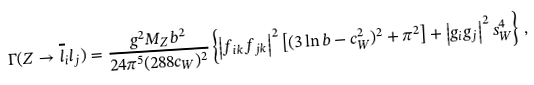<formula> <loc_0><loc_0><loc_500><loc_500>\Gamma ( Z \to \overline { l } _ { i } l _ { j } ) = \frac { g ^ { 2 } M _ { Z } b ^ { 2 } } { 2 4 \pi ^ { 5 } ( 2 8 8 c _ { W } ) ^ { 2 } } \left \{ \left | f _ { i k } f _ { j k } \right | ^ { 2 } \left [ ( 3 \ln b - c _ { W } ^ { 2 } ) ^ { 2 } + \pi ^ { 2 } \right ] + \left | g _ { i } g _ { j } \right | ^ { 2 } s _ { W } ^ { 4 } \right \} \, ,</formula> 